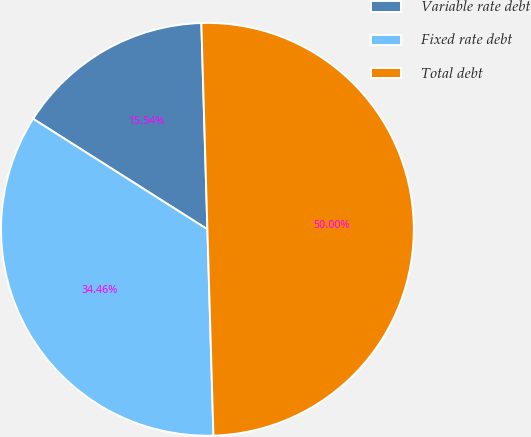<chart> <loc_0><loc_0><loc_500><loc_500><pie_chart><fcel>Variable rate debt<fcel>Fixed rate debt<fcel>Total debt<nl><fcel>15.54%<fcel>34.46%<fcel>50.0%<nl></chart> 